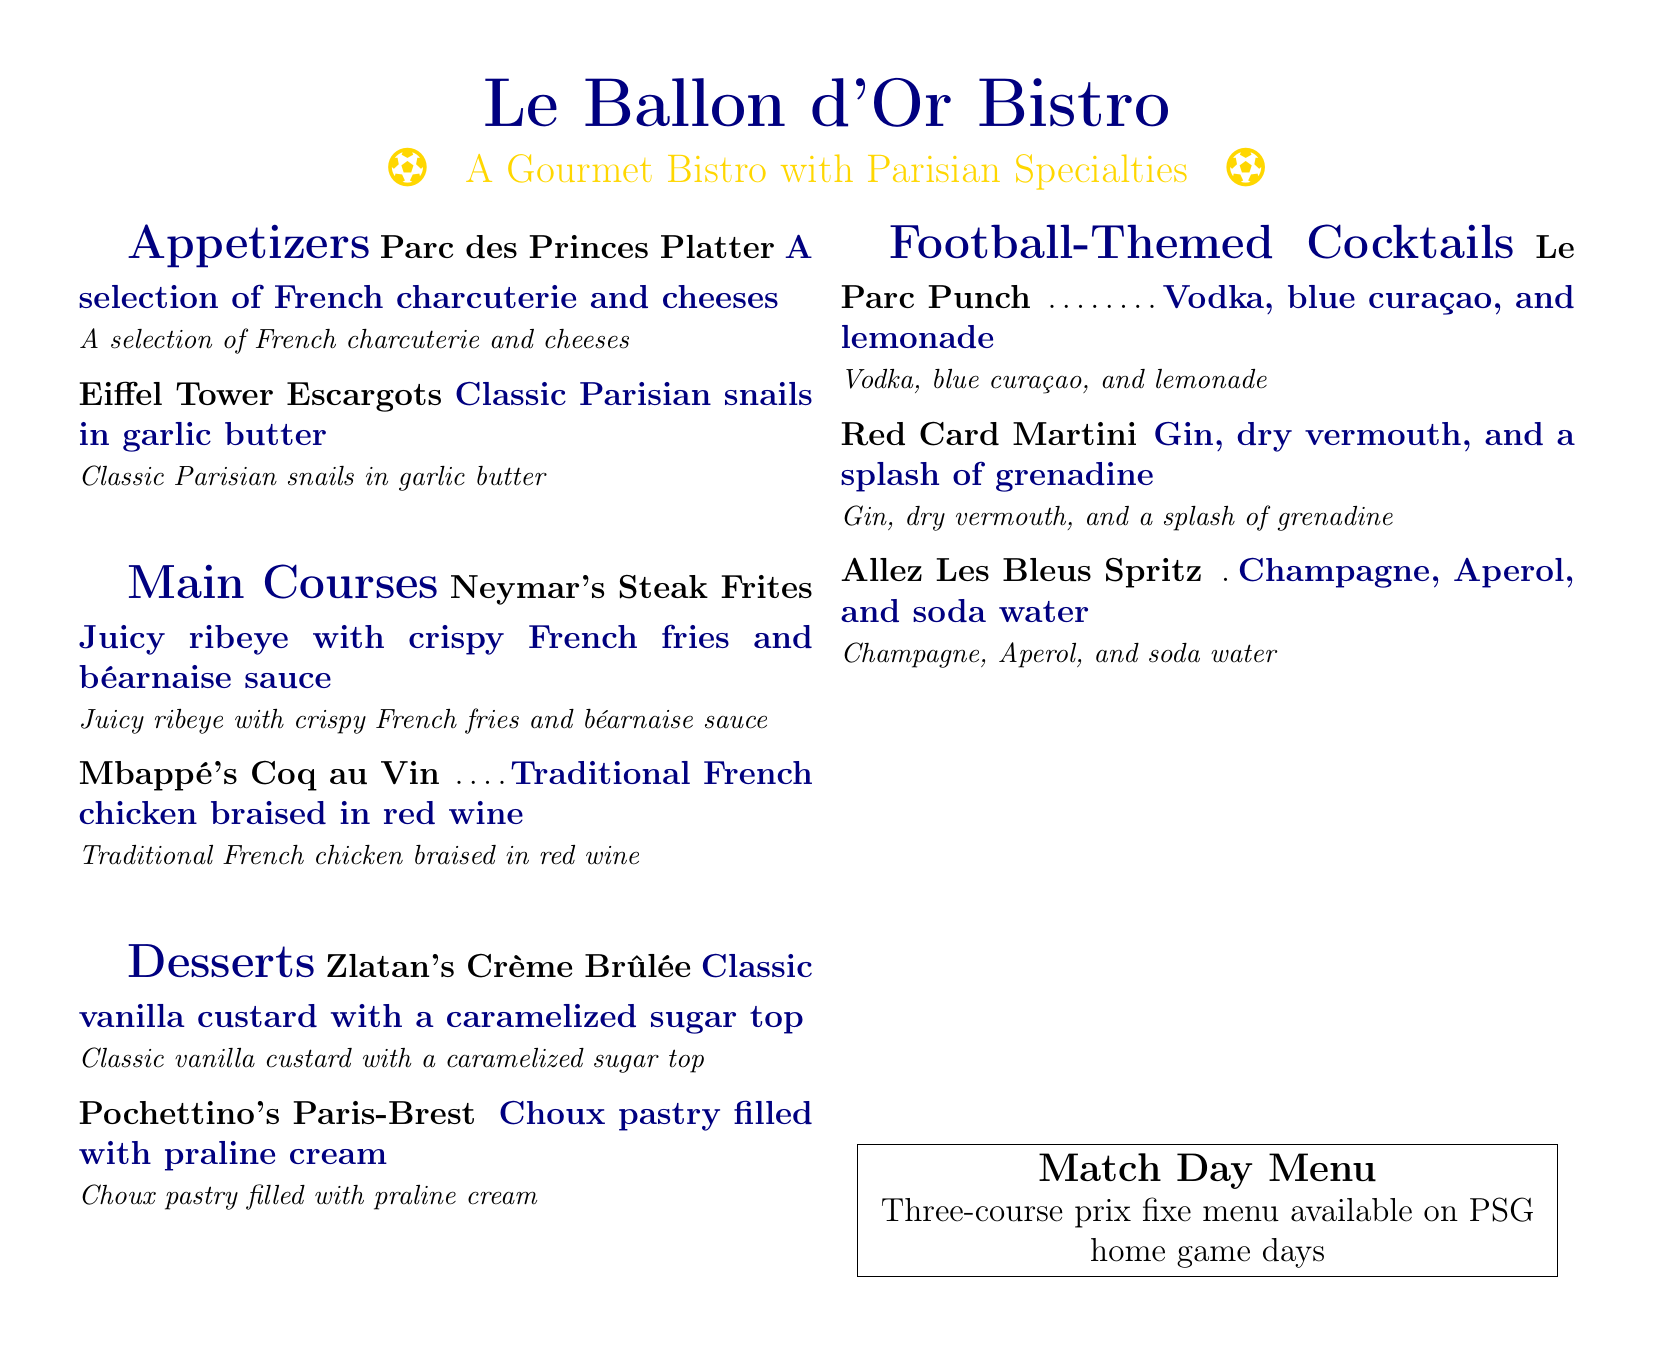What is the name of the bistro? The name of the bistro is found in the title of the document.
Answer: Le Ballon d'Or Bistro What is the signature appetizer? The signature appetizer is listed as the first item under Appetizers.
Answer: Parc des Princes Platter What type of meat is used in Neymar's dish? Neymar's dish is focused on a specific type of steak.
Answer: Ribeye What is the main ingredient in Mbappé's Coq au Vin? The main ingredient of this dish is derived from the title.
Answer: Chicken What cocktail contains vodka? The cocktail is mentioned in the Football-Themed Cocktails section.
Answer: Le Parc Punch How many desserts are listed on the menu? The number of desserts can be tallied from the Desserts section.
Answer: Two What is the main spirit in the Red Card Martini? The main spirit is specified in the cocktail's ingredients.
Answer: Gin What dessert includes praline cream? The dessert featuring praline cream is noted in the Desserts section.
Answer: Pochettino's Paris-Brest What special menu is available on PSG game days? The special menu is mentioned in a box at the bottom of the document.
Answer: Match Day Menu 